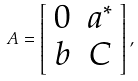<formula> <loc_0><loc_0><loc_500><loc_500>A = \left [ \begin{array} { c c } 0 & a ^ { * } \\ b & C \end{array} \right ] ,</formula> 